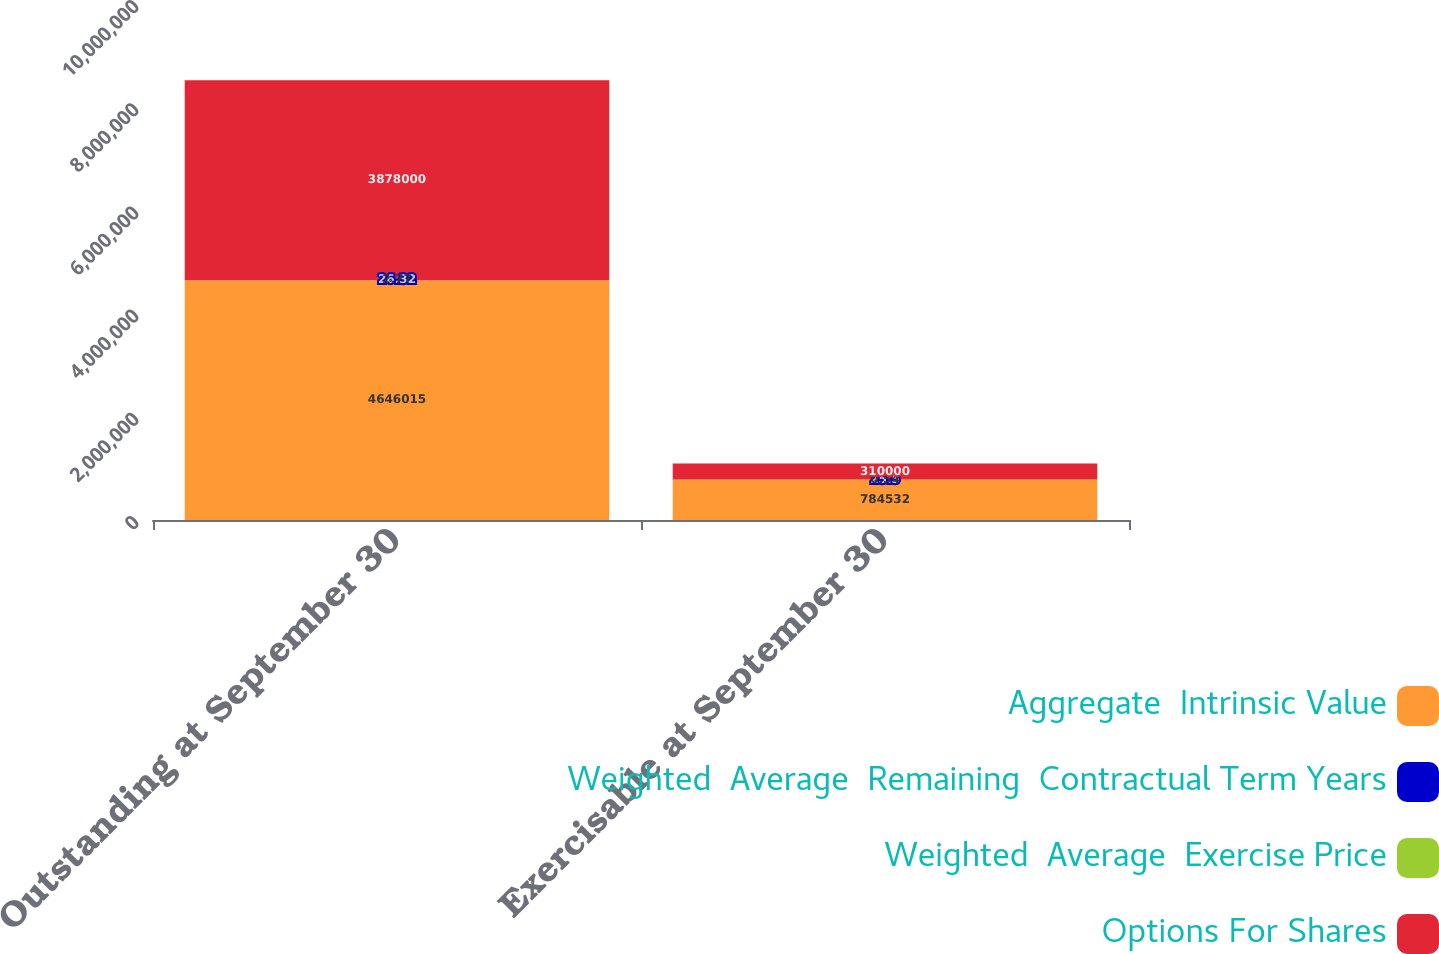<chart> <loc_0><loc_0><loc_500><loc_500><stacked_bar_chart><ecel><fcel>Outstanding at September 30<fcel>Exercisable at September 30<nl><fcel>Aggregate  Intrinsic Value<fcel>4.64602e+06<fcel>784532<nl><fcel>Weighted  Average  Remaining  Contractual Term Years<fcel>26.32<fcel>25.5<nl><fcel>Weighted  Average  Exercise Price<fcel>2.77<fcel>0.54<nl><fcel>Options For Shares<fcel>3.878e+06<fcel>310000<nl></chart> 